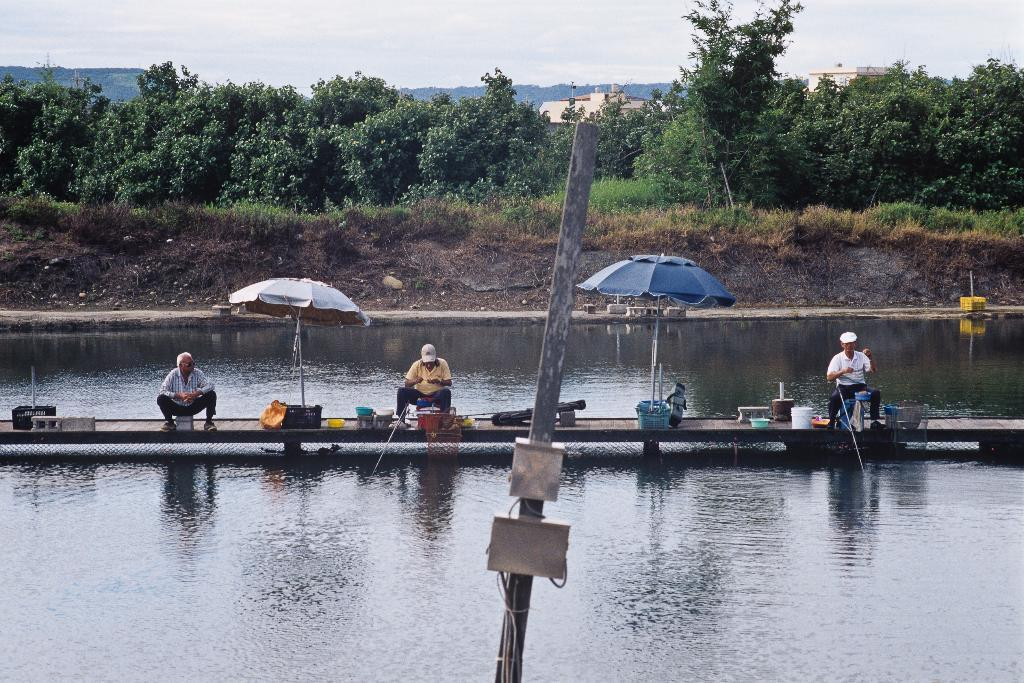What are the people in the image doing? There are persons sitting in the image. What objects are being used to provide shade in the image? Umbrellas are visible in the image. What material is the pole made of in the image? There is a wooden pole in the image. What is the primary substance surrounding the people in the image? Water is present in the image. What type of vegetation can be seen in the background of the image? Trees are present in the background of the image. What is visible in the sky in the image? Clouds are present in the sky. What type of brush is being used to expand the trees in the image? There is no brush or expansion of trees present in the image. 